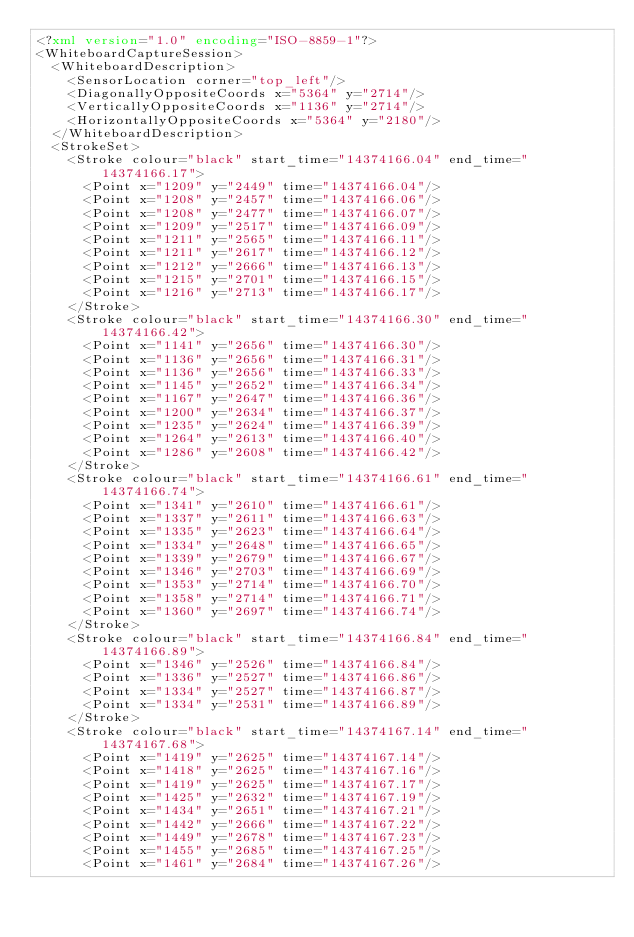Convert code to text. <code><loc_0><loc_0><loc_500><loc_500><_XML_><?xml version="1.0" encoding="ISO-8859-1"?>
<WhiteboardCaptureSession>
  <WhiteboardDescription>
    <SensorLocation corner="top_left"/>
    <DiagonallyOppositeCoords x="5364" y="2714"/>
    <VerticallyOppositeCoords x="1136" y="2714"/>
    <HorizontallyOppositeCoords x="5364" y="2180"/>
  </WhiteboardDescription>
  <StrokeSet>
    <Stroke colour="black" start_time="14374166.04" end_time="14374166.17">
      <Point x="1209" y="2449" time="14374166.04"/>
      <Point x="1208" y="2457" time="14374166.06"/>
      <Point x="1208" y="2477" time="14374166.07"/>
      <Point x="1209" y="2517" time="14374166.09"/>
      <Point x="1211" y="2565" time="14374166.11"/>
      <Point x="1211" y="2617" time="14374166.12"/>
      <Point x="1212" y="2666" time="14374166.13"/>
      <Point x="1215" y="2701" time="14374166.15"/>
      <Point x="1216" y="2713" time="14374166.17"/>
    </Stroke>
    <Stroke colour="black" start_time="14374166.30" end_time="14374166.42">
      <Point x="1141" y="2656" time="14374166.30"/>
      <Point x="1136" y="2656" time="14374166.31"/>
      <Point x="1136" y="2656" time="14374166.33"/>
      <Point x="1145" y="2652" time="14374166.34"/>
      <Point x="1167" y="2647" time="14374166.36"/>
      <Point x="1200" y="2634" time="14374166.37"/>
      <Point x="1235" y="2624" time="14374166.39"/>
      <Point x="1264" y="2613" time="14374166.40"/>
      <Point x="1286" y="2608" time="14374166.42"/>
    </Stroke>
    <Stroke colour="black" start_time="14374166.61" end_time="14374166.74">
      <Point x="1341" y="2610" time="14374166.61"/>
      <Point x="1337" y="2611" time="14374166.63"/>
      <Point x="1335" y="2623" time="14374166.64"/>
      <Point x="1334" y="2648" time="14374166.65"/>
      <Point x="1339" y="2679" time="14374166.67"/>
      <Point x="1346" y="2703" time="14374166.69"/>
      <Point x="1353" y="2714" time="14374166.70"/>
      <Point x="1358" y="2714" time="14374166.71"/>
      <Point x="1360" y="2697" time="14374166.74"/>
    </Stroke>
    <Stroke colour="black" start_time="14374166.84" end_time="14374166.89">
      <Point x="1346" y="2526" time="14374166.84"/>
      <Point x="1336" y="2527" time="14374166.86"/>
      <Point x="1334" y="2527" time="14374166.87"/>
      <Point x="1334" y="2531" time="14374166.89"/>
    </Stroke>
    <Stroke colour="black" start_time="14374167.14" end_time="14374167.68">
      <Point x="1419" y="2625" time="14374167.14"/>
      <Point x="1418" y="2625" time="14374167.16"/>
      <Point x="1419" y="2625" time="14374167.17"/>
      <Point x="1425" y="2632" time="14374167.19"/>
      <Point x="1434" y="2651" time="14374167.21"/>
      <Point x="1442" y="2666" time="14374167.22"/>
      <Point x="1449" y="2678" time="14374167.23"/>
      <Point x="1455" y="2685" time="14374167.25"/>
      <Point x="1461" y="2684" time="14374167.26"/></code> 